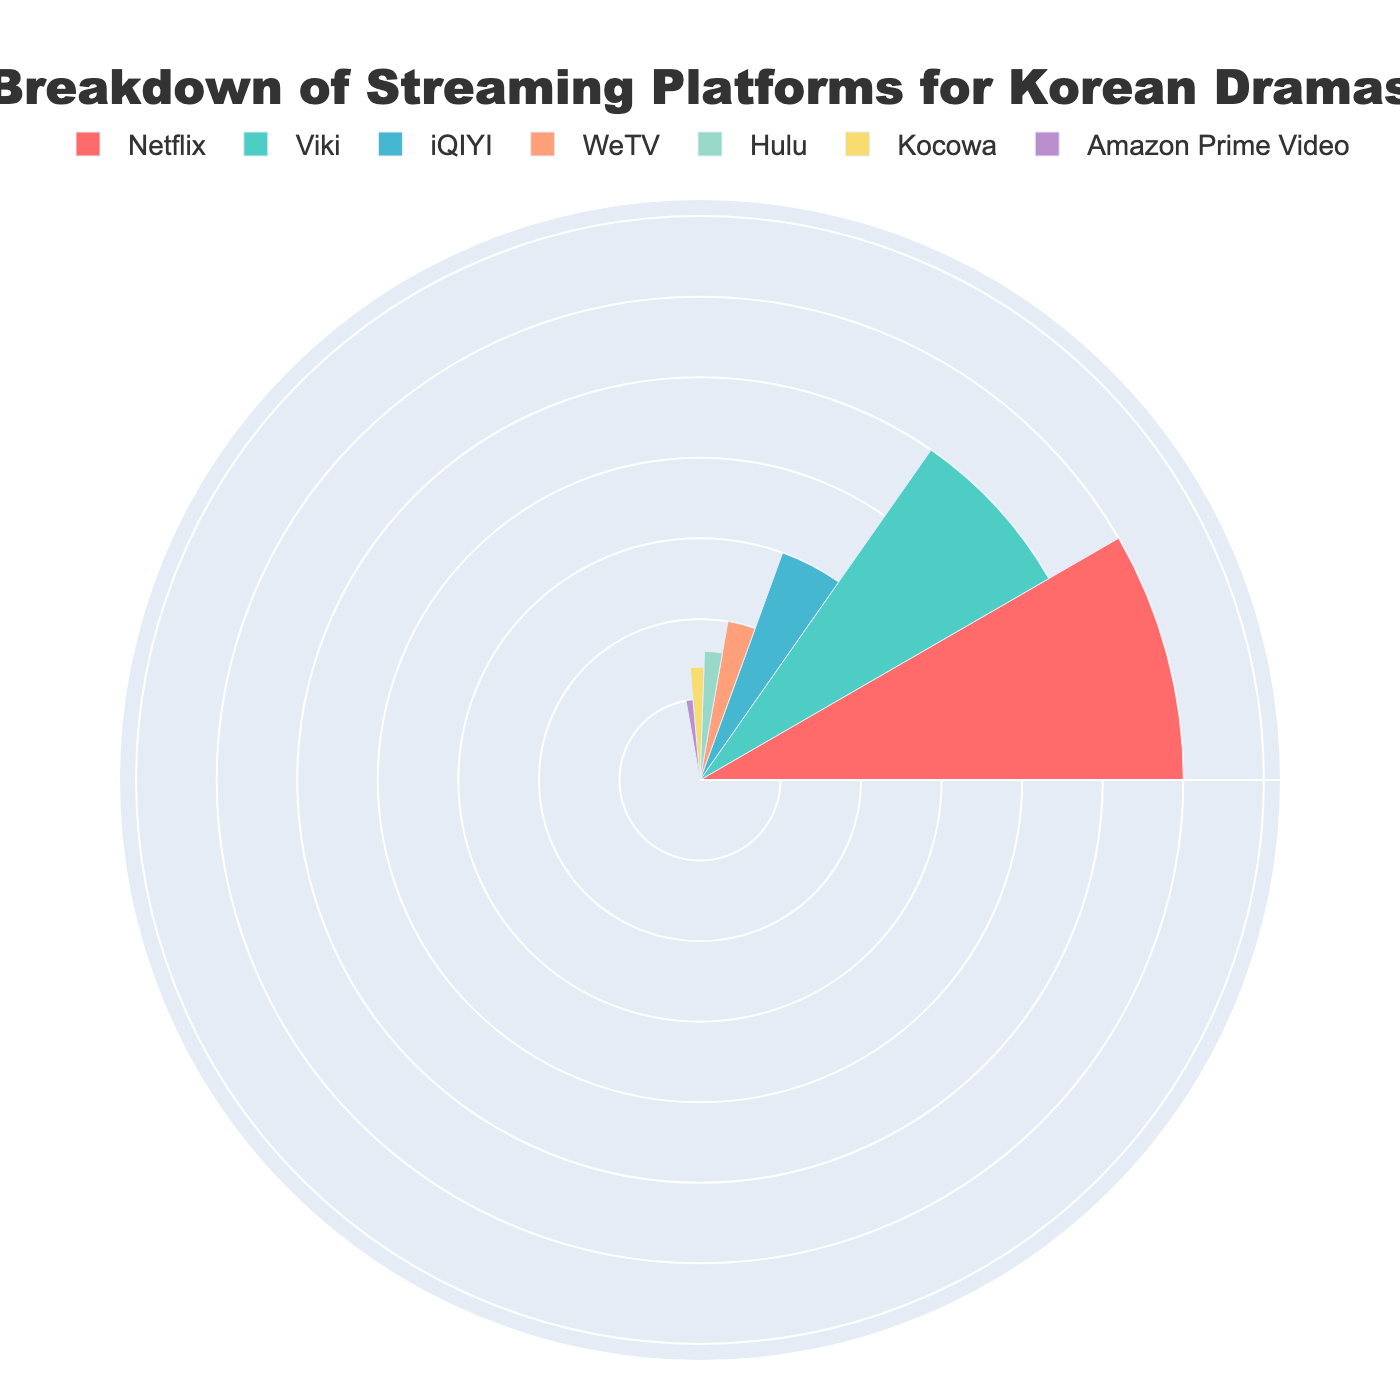What's the title of the figure? The title is usually placed at the top of the figure. In this case, the plot's title is given in the layout section.
Answer: "Breakdown of Streaming Platforms for Korean Dramas" Which platform has the highest percentage of streaming? In the figure, the platform with the highest value will have the largest segment/polar bar. From the data, Netflix leads with 30%.
Answer: Netflix Which two platforms have the smallest percentages, and what are they? The smallest percentages will correspond to the shortest segments/polar bars. From the data, the smallest percentages are 5% for Amazon Prime Video and 7% for Kocowa.
Answer: Amazon Prime Video and Kocowa How many platforms have a percentage of 10% or higher? By examining each segment/polar bar, count the number of platforms equal to or exceeding 10%: Netflix (30), Viki (25), iQIYI (15), and WeTV (10).
Answer: 4 What is the combined percentage of Viki and iQIYI? Add the percentages of Viki (25%) and iQIYI (15%) together: 25 + 15 = 40
Answer: 40% Is the percentage of Hulu greater or smaller than Kocowa? Compare the percentages directly. Hulu has 8% while Kocowa has 7%, thus Hulu is greater.
Answer: Greater How do Netflix and Hulu's percentages compare? Subtract Hulu's percentage (8%) from Netflix's percentage (30%): 30 - 8 = 22. Netflix's percentage is 22% higher than Hulu's.
Answer: 22% higher What percentage of platforms have less than 10% share each? Identify platforms with less than 10%: Hulu (8%), Kocowa (7%), Amazon Prime Video (5%).
Answer: 3 platforms What is the average percentage of the three platforms with the highest percentages? Identify the top three percentages: Netflix (30%), Viki (25%), and iQIYI (15%). Calculate: (30 + 25 + 15) / 3 = 70 / 3 ≈ 23.33
Answer: 23.33% If Viki and iQIYI were combined into a single platform, what percentage of the total would they hold? Sum Viki and iQIYI: 25% + 15% = 40%. This new combined platform would hold 40% of the total.
Answer: 40% 